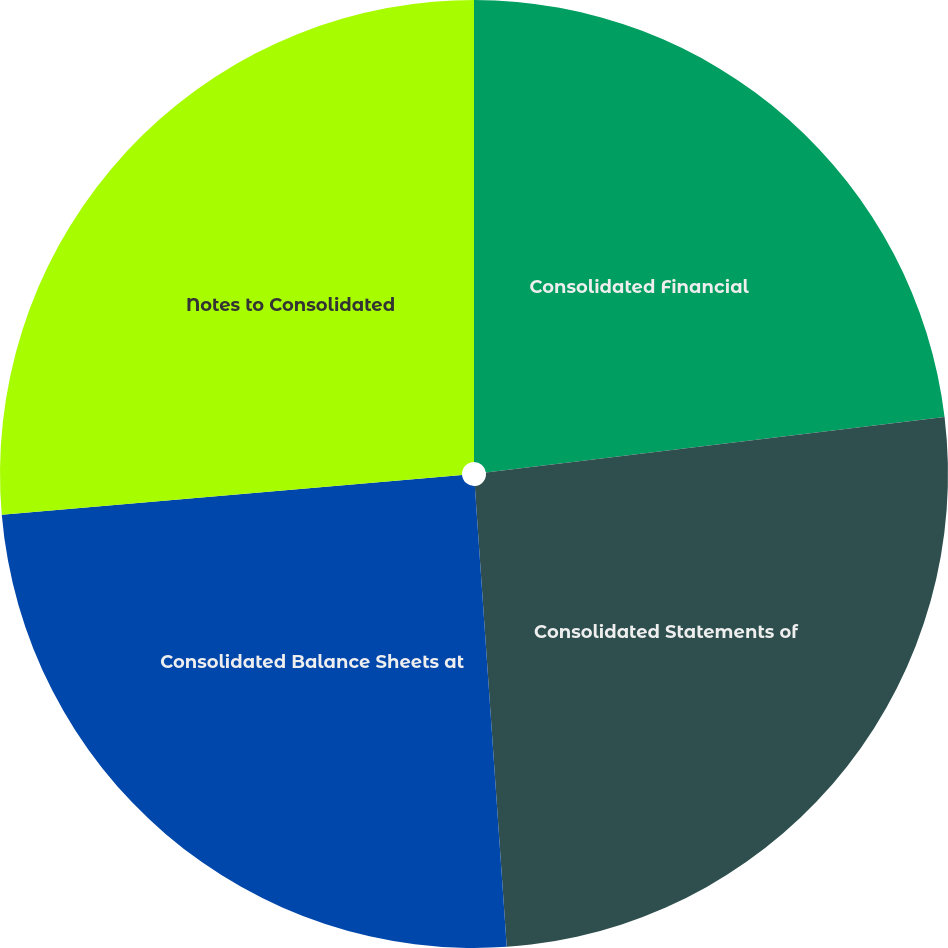Convert chart. <chart><loc_0><loc_0><loc_500><loc_500><pie_chart><fcel>Consolidated Financial<fcel>Consolidated Statements of<fcel>Consolidated Balance Sheets at<fcel>Notes to Consolidated<nl><fcel>23.08%<fcel>25.82%<fcel>24.73%<fcel>26.37%<nl></chart> 